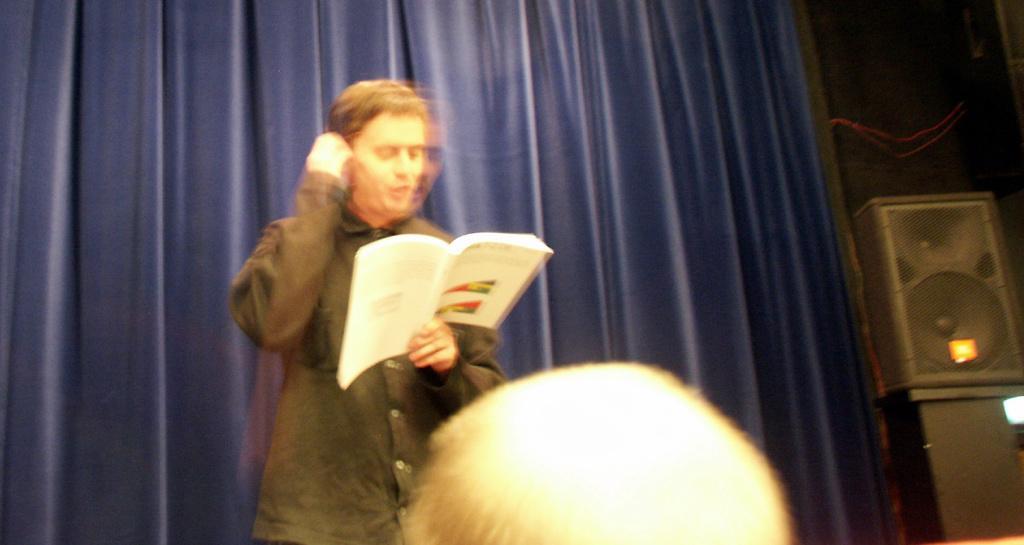Can you describe this image briefly? In this image I can see a man standing facing towards the right and holding a book in his hand. I can see speakers on the right side of the image a curtain behind the person standing. I can see another person at the bottom of the image. 